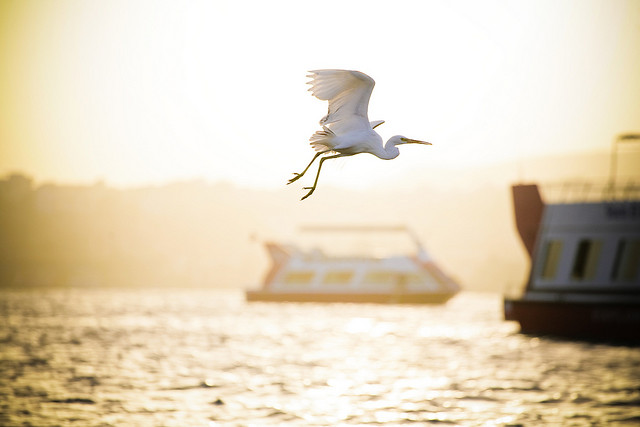Please provide a short description for this region: [0.78, 0.37, 1.0, 0.72]. The right side of the image features a ship. 